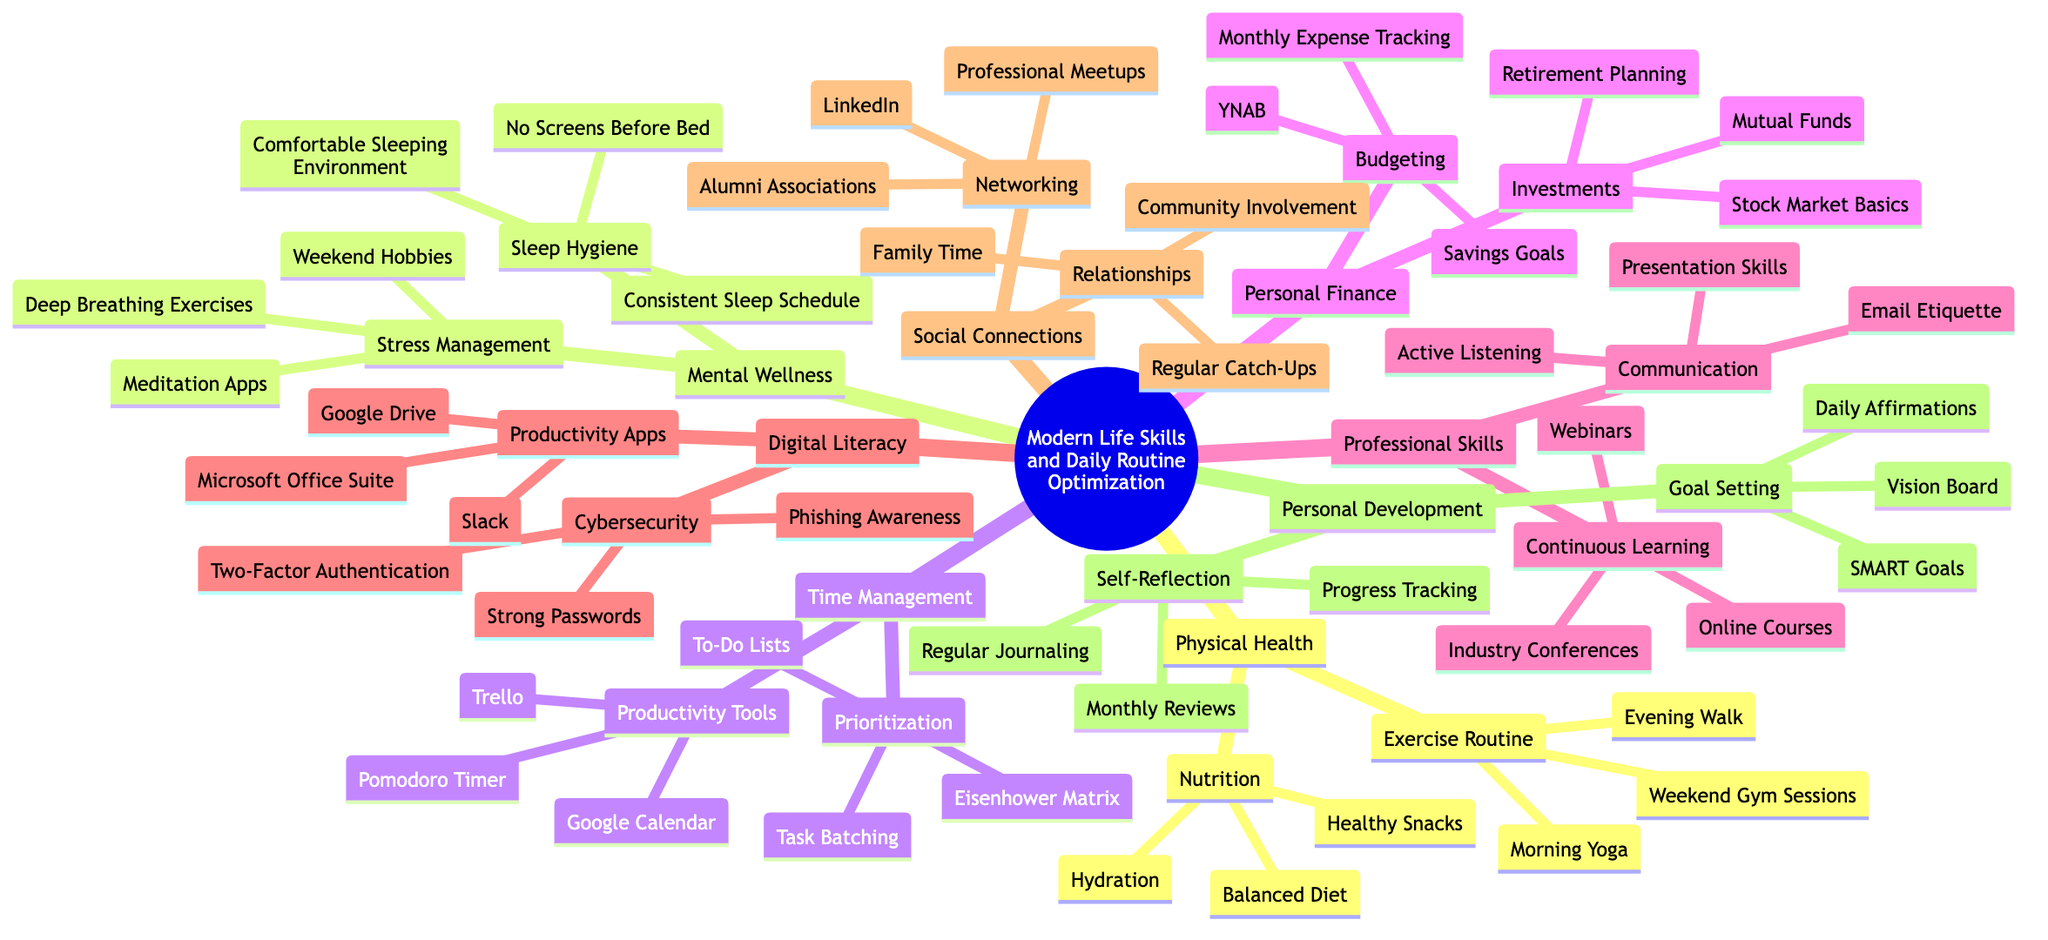What are the categories under "Modern Life Skills and Daily Routine Optimization"? The main categories listed under the root node "Modern Life Skills and Daily Routine Optimization" are Physical Health, Mental Wellness, Time Management, Personal Finance, Professional Skills, Digital Literacy, Social Connections, and Personal Development.
Answer: Physical Health, Mental Wellness, Time Management, Personal Finance, Professional Skills, Digital Literacy, Social Connections, Personal Development How many exercises are listed under "Exercise Routine"? In the "Exercise Routine" section, there are three listed activities: Morning Yoga, Evening Walk, and Weekend Gym Sessions. Adding these gives a total of 3 exercises.
Answer: 3 What is the focus of the "Personal Finance" category? The "Personal Finance" category focuses on two main areas: Budgeting and Investments. This shows a dual approach to managing personal finances effectively.
Answer: Budgeting and Investments Which app is mentioned in both "Time Management" and "Digital Literacy"? The app "Google Calendar" appears in the "Time Management" category under Productivity Tools. In Digital Literacy, it is mentioned under Productivity Apps. This overlap indicates its utility in both categories.
Answer: Google Calendar What are the two main subcategories under "Mental Wellness"? The two main subcategories under "Mental Wellness" are Stress Management and Sleep Hygiene. Both are essential for maintaining good mental health in daily life.
Answer: Stress Management, Sleep Hygiene How many skills are listed under "Professional Skills" in total? Under "Professional Skills", there are two primary subcategories: Communication and Continuous Learning. Each subcategory contains three skills, leading to a total of 6 skills in this category.
Answer: 6 What method is mentioned for budgeting in "Personal Finance"? The budgeting method mentioned is "YNAB (You Need A Budget)", which is a specific tool that provides structured financial planning assistance.
Answer: YNAB (You Need A Budget) Which two nodes relate to personal reflection in the "Personal Development" category? In the "Personal Development" category, the nodes related to personal reflection are Goal Setting and Self-Reflection. Each node contributes essential practices for self-improvement.
Answer: Goal Setting, Self-Reflection What specific method from "Time Management" helps prioritize tasks? The Eisenhower Matrix is specified as a method under "Prioritization" in the "Time Management" category, which helps users determine task urgency and importance effectively.
Answer: Eisenhower Matrix 